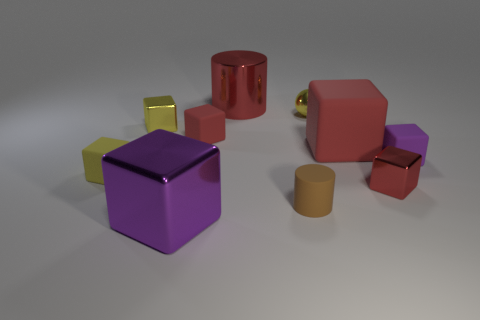Subtract all red cubes. How many were subtracted if there are1red cubes left? 2 Subtract all yellow blocks. How many blocks are left? 5 Subtract all purple cubes. How many cubes are left? 5 Subtract all green cylinders. How many yellow blocks are left? 2 Subtract 3 cubes. How many cubes are left? 4 Subtract all gray cubes. Subtract all green cylinders. How many cubes are left? 7 Subtract 0 brown blocks. How many objects are left? 10 Subtract all cubes. How many objects are left? 3 Subtract all large red matte things. Subtract all red metal objects. How many objects are left? 7 Add 3 metal spheres. How many metal spheres are left? 4 